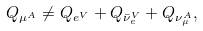<formula> <loc_0><loc_0><loc_500><loc_500>Q _ { \mu ^ { A } } \neq Q _ { e ^ { V } } + Q _ { { \bar { \nu } _ { e } ^ { V } } } + Q _ { \nu _ { \mu } ^ { A } } ,</formula> 